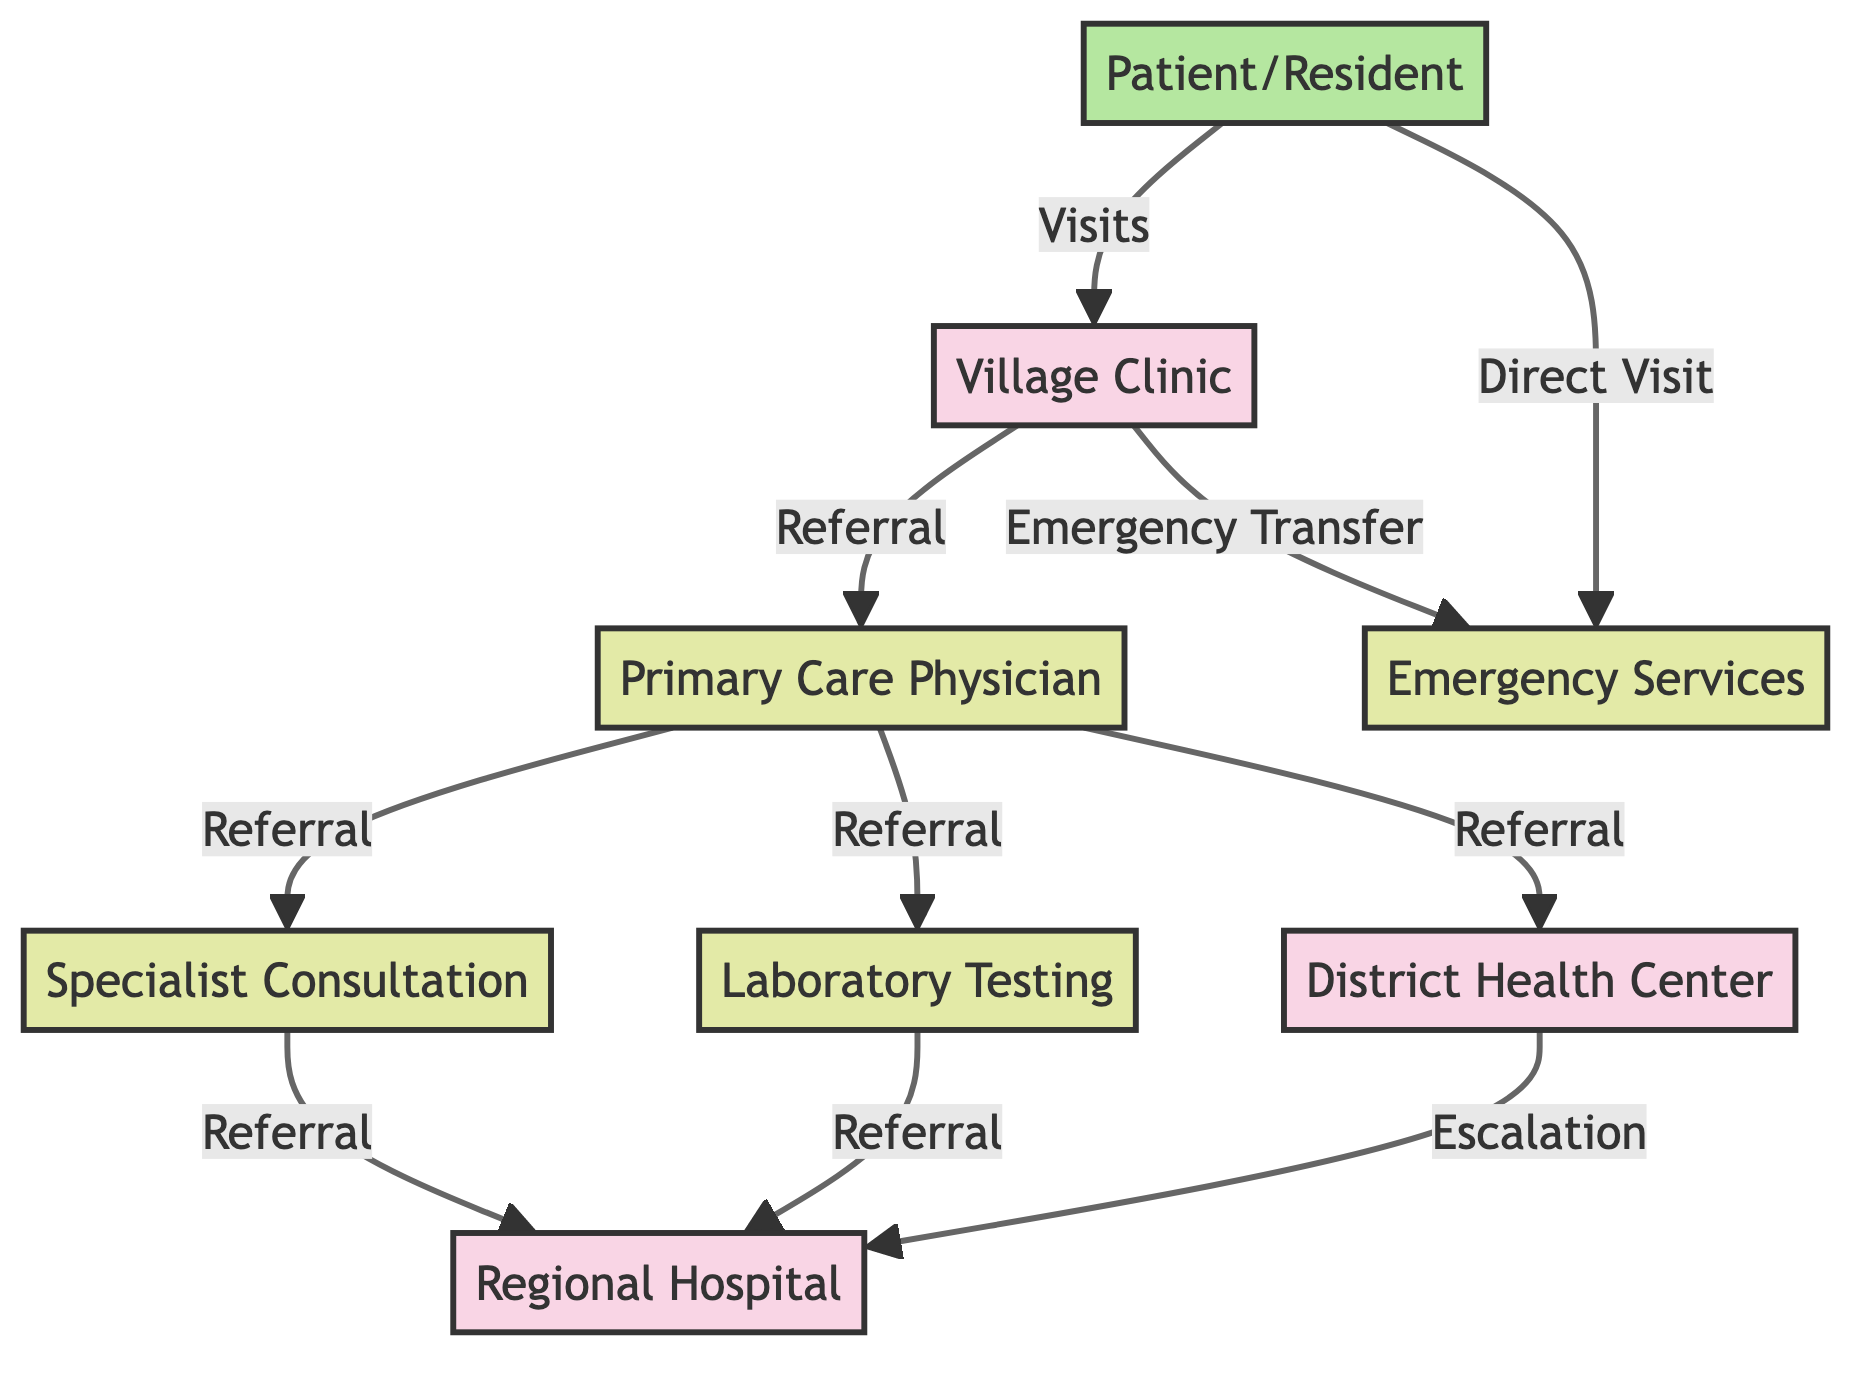What's the total number of nodes in the diagram? There are 8 nodes listed in the data provided: Village Clinic, District Health Center, Regional Hospital, Primary Care Physician, Specialist Consultation, Laboratory Testing, Emergency Services, and Patient/Resident.
Answer: 8 What is the starting point for a patient seeking health services? The patient starts at the Village Clinic, as indicated by the directed arrow showing "Visits" from Patient/Resident to Village Clinic.
Answer: Village Clinic Which health service can be directly accessed from the Village Clinic? The Village Clinic refers directly to a Primary Care Physician, as shown by the edge labeled "Referral" from Village Clinic to Primary Care Physician.
Answer: Primary Care Physician How many referral pathways lead from the Primary Care Physician? The Primary Care Physician has three direct referral pathways: to the District Health Center, Specialist Consultation, and Laboratory Testing.
Answer: 3 Which access point does a Specialist Consultation lead to? The Specialist Consultation refers a patient to the Regional Hospital based on the edge labeled "Referral" connecting the two.
Answer: Regional Hospital What are the two ways a patient can reach Emergency Services? A patient can either be referred from the Village Clinic or visit directly, as shown by the edges "Emergency Transfer" and "Direct Visit."
Answer: Village Clinic and Patient/Resident Which access point is escalated from the District Health Center? The District Health Center escalates to the Regional Hospital as indicated by the edge labeled "Escalation."
Answer: Regional Hospital What is the connection between Laboratory Testing and the Regional Hospital? Laboratory Testing refers to the Regional Hospital, as indicated by the edge labeled "Referral" connecting Laboratory Testing to Regional Hospital.
Answer: Regional Hospital 